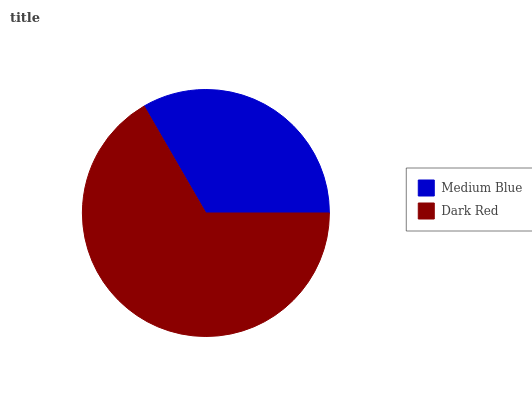Is Medium Blue the minimum?
Answer yes or no. Yes. Is Dark Red the maximum?
Answer yes or no. Yes. Is Dark Red the minimum?
Answer yes or no. No. Is Dark Red greater than Medium Blue?
Answer yes or no. Yes. Is Medium Blue less than Dark Red?
Answer yes or no. Yes. Is Medium Blue greater than Dark Red?
Answer yes or no. No. Is Dark Red less than Medium Blue?
Answer yes or no. No. Is Dark Red the high median?
Answer yes or no. Yes. Is Medium Blue the low median?
Answer yes or no. Yes. Is Medium Blue the high median?
Answer yes or no. No. Is Dark Red the low median?
Answer yes or no. No. 